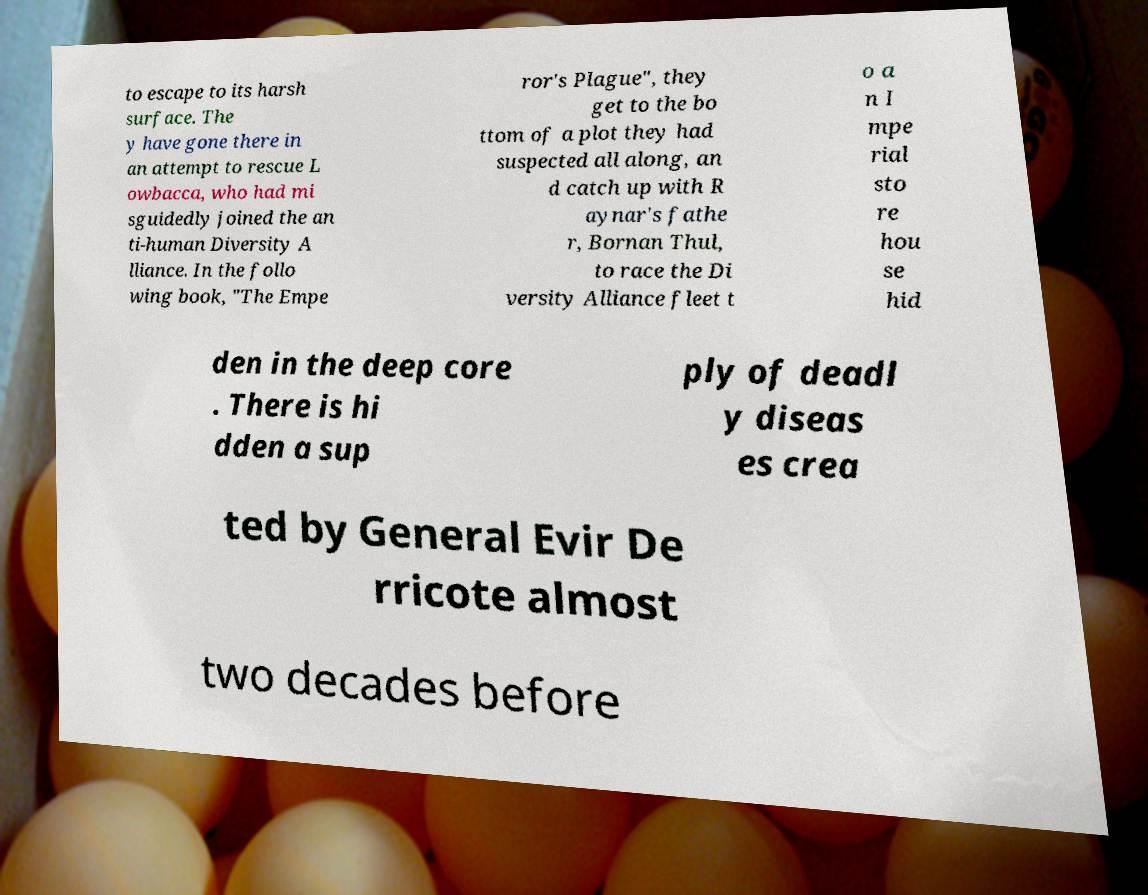For documentation purposes, I need the text within this image transcribed. Could you provide that? to escape to its harsh surface. The y have gone there in an attempt to rescue L owbacca, who had mi sguidedly joined the an ti-human Diversity A lliance. In the follo wing book, "The Empe ror's Plague", they get to the bo ttom of a plot they had suspected all along, an d catch up with R aynar's fathe r, Bornan Thul, to race the Di versity Alliance fleet t o a n I mpe rial sto re hou se hid den in the deep core . There is hi dden a sup ply of deadl y diseas es crea ted by General Evir De rricote almost two decades before 